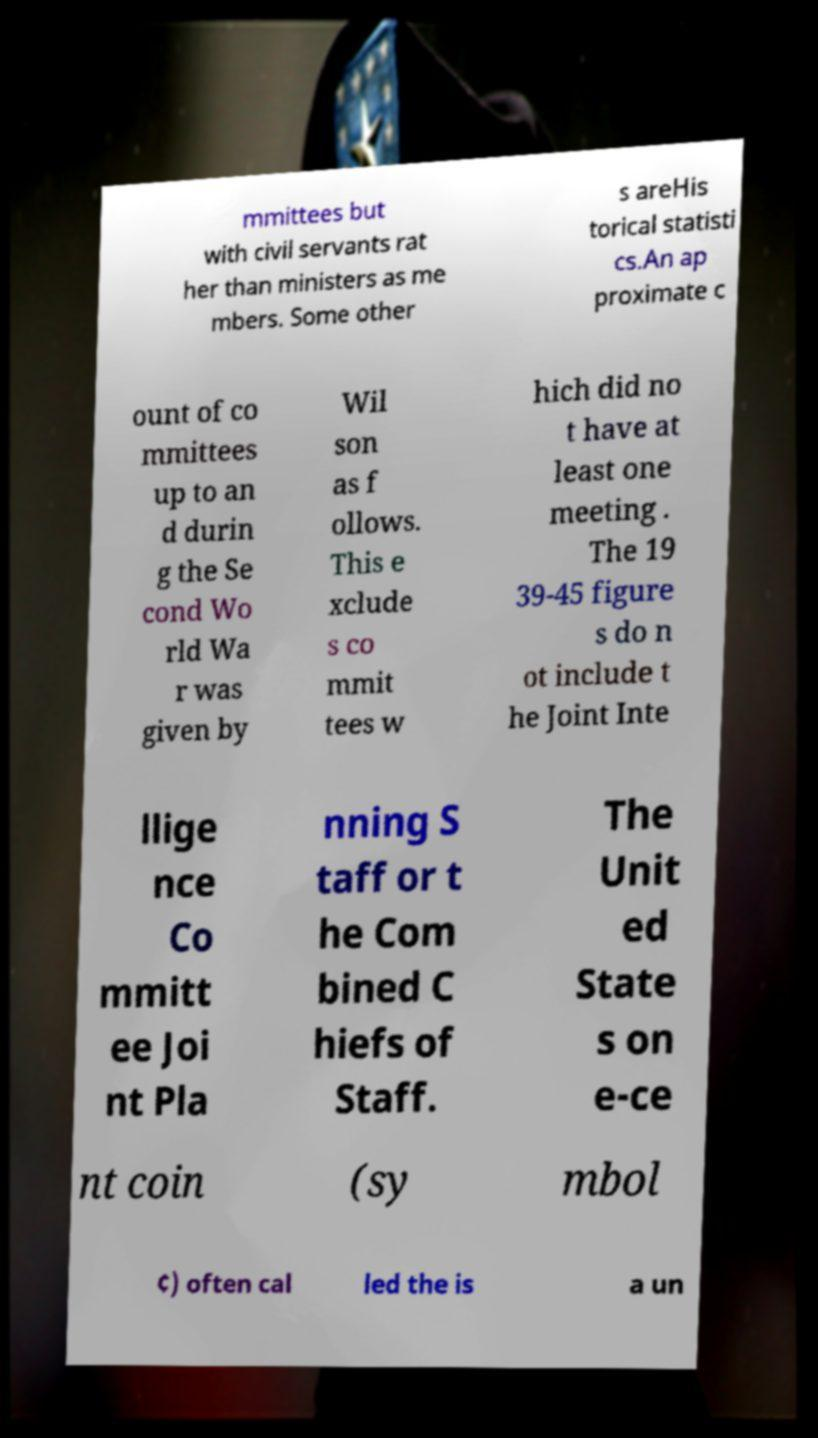Could you extract and type out the text from this image? mmittees but with civil servants rat her than ministers as me mbers. Some other s areHis torical statisti cs.An ap proximate c ount of co mmittees up to an d durin g the Se cond Wo rld Wa r was given by Wil son as f ollows. This e xclude s co mmit tees w hich did no t have at least one meeting . The 19 39-45 figure s do n ot include t he Joint Inte llige nce Co mmitt ee Joi nt Pla nning S taff or t he Com bined C hiefs of Staff. The Unit ed State s on e-ce nt coin (sy mbol ¢) often cal led the is a un 